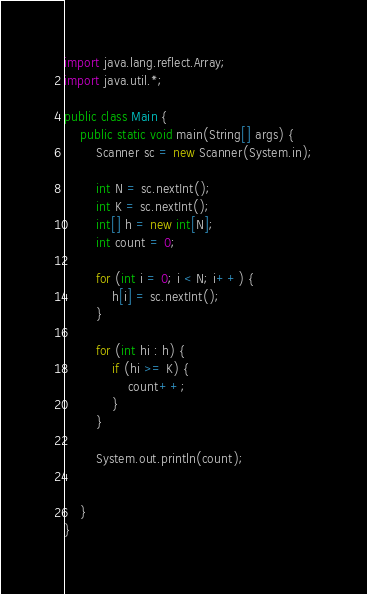<code> <loc_0><loc_0><loc_500><loc_500><_Java_>import java.lang.reflect.Array;
import java.util.*;

public class Main {
    public static void main(String[] args) {
        Scanner sc = new Scanner(System.in);

        int N = sc.nextInt();
        int K = sc.nextInt();
        int[] h = new int[N];
        int count = 0;

        for (int i = 0; i < N; i++) {
            h[i] = sc.nextInt();
        }

        for (int hi : h) {
            if (hi >= K) {
                count++;
            }
        }

        System.out.println(count);


    }
}



</code> 